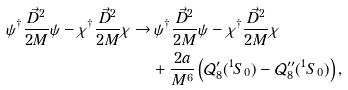<formula> <loc_0><loc_0><loc_500><loc_500>\psi ^ { \dag } \frac { \vec { D } ^ { 2 } } { 2 M } \psi - \chi ^ { \dag } \frac { \vec { D } ^ { 2 } } { 2 M } \chi \rightarrow & \, \psi ^ { \dag } \frac { \vec { D } ^ { 2 } } { 2 M } \psi - \chi ^ { \dag } \frac { \vec { D } ^ { 2 } } { 2 M } \chi \\ & + \frac { 2 a } { M ^ { 6 } } \left ( \mathcal { Q } ^ { \prime } _ { 8 } ( ^ { 1 } S _ { 0 } ) - \mathcal { Q } ^ { \prime \prime } _ { 8 } ( ^ { 1 } S _ { 0 } ) \right ) ,</formula> 